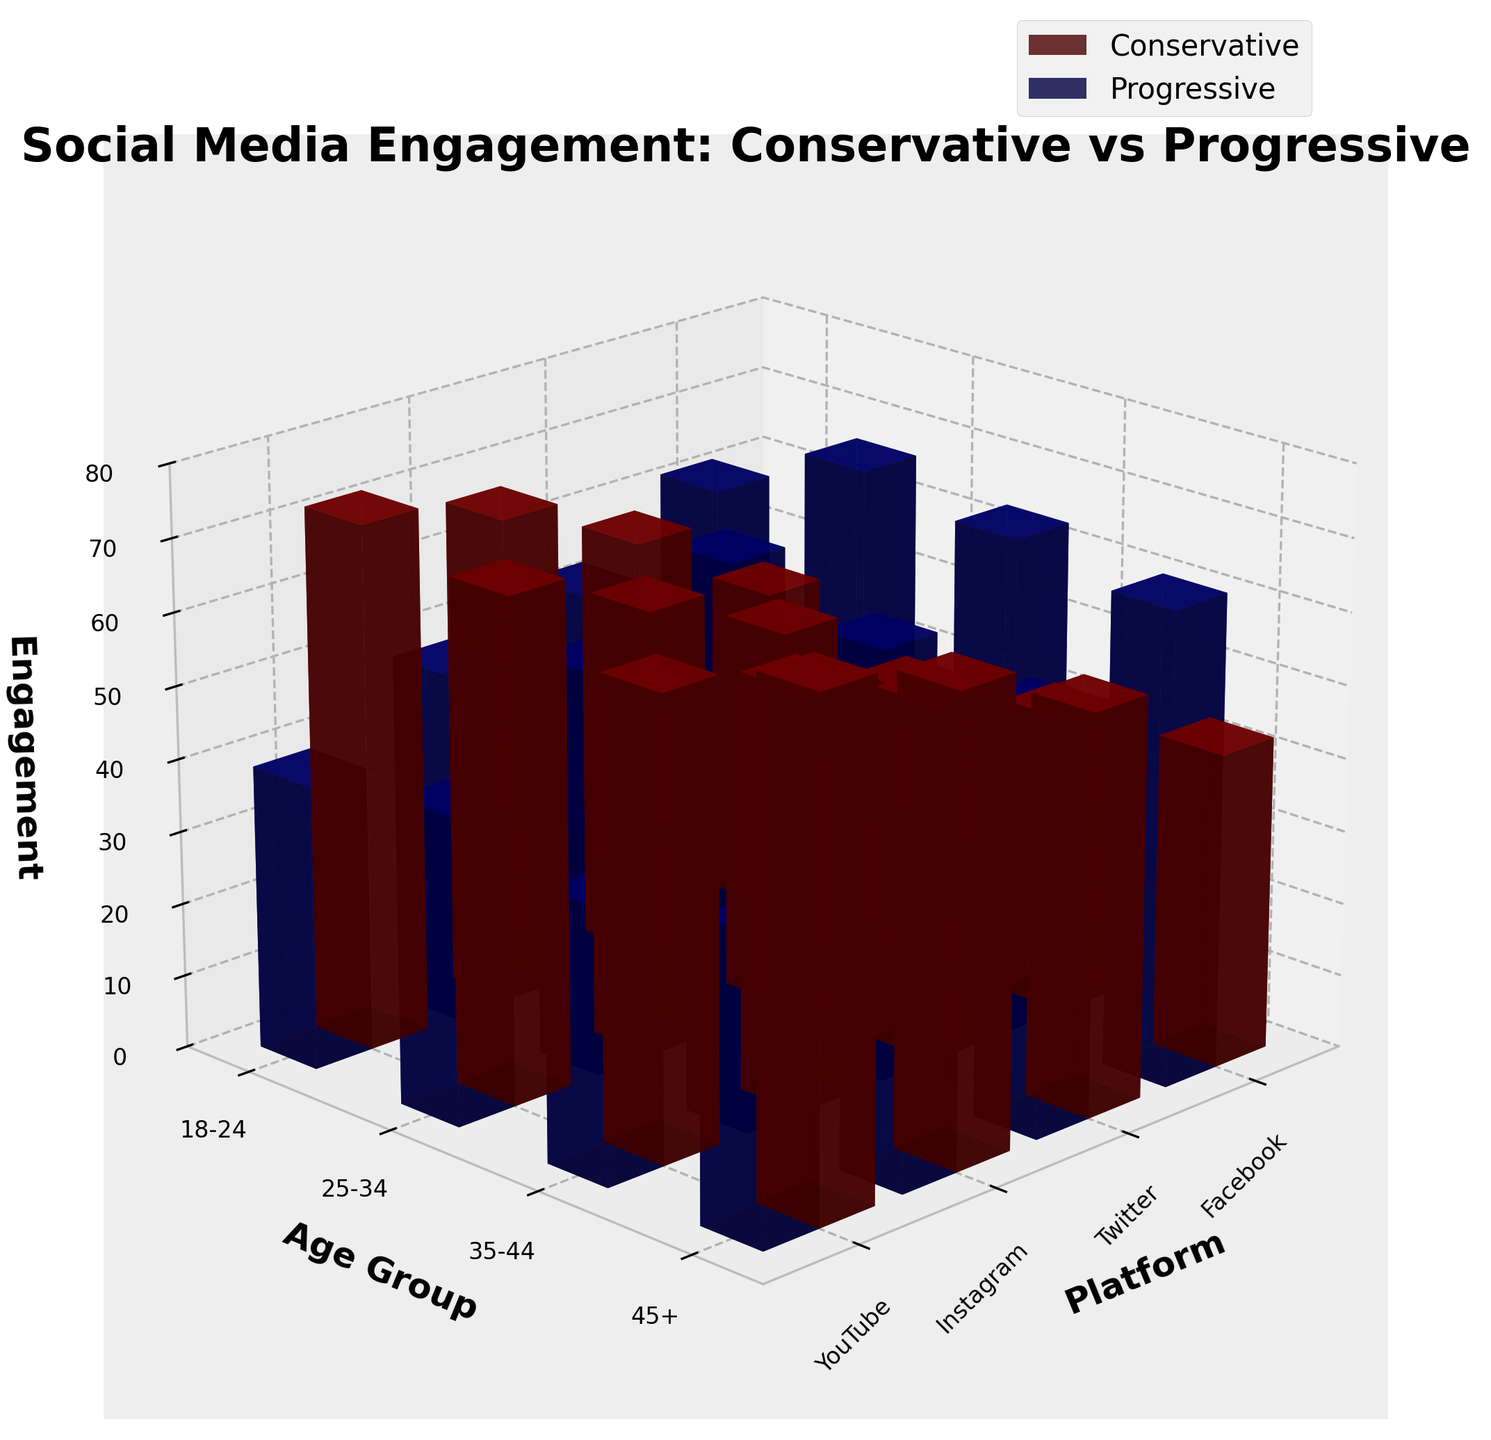What is the title of the figure? The title of the figure is located at the top of the plot and generally provides a summary of what the figure represents. In this case, the title mentions social media engagement for conservative vs. progressive content.
Answer: Social Media Engagement: Conservative vs Progressive How are the platforms and age groups represented on the axes? The platforms are labeled on the x-axis, while the age groups are labeled on the y-axis. The z-axis measures the engagement levels.
Answer: Platforms: x-axis, Age groups: y-axis, Engagement: z-axis Which platform shows the highest conservative engagement for the 45+ age group? To find the highest conservative engagement for the 45+ group, look at the bars for the 45+ age group across all platforms and compare their heights. The tallest bar represents the highest engagement. This bar appears on Facebook.
Answer: Facebook Compare the progressive engagement for the 18-24 age group on Twitter and Instagram. Which is higher? Analyze the heights of the bars for the 18-24 age group under Twitter and Instagram. The higher bar represents greater engagement. On Twitter, the engagement is higher for progressive content in this age group.
Answer: Twitter What is the difference in engagement between conservative and progressive content on Facebook for the 25-34 age group? Subtract the conservative engagement value from the progressive engagement value for Facebook in the 25-34 age group (53 - 58). The difference is 5.
Answer: 5 What is the average conservative engagement for YouTube across all age groups? Add the conservative engagement values for YouTube across all age groups and divide by the number of age groups (43 + 55 + 64 + 70) / 4. This results in 58.
Answer: 58 Which age group displays the largest disparity between conservative and progressive engagement on Instagram? Compare the absolute differences between conservative and progressive engagement values for each age group on Instagram: (68 - 41), (59 - 49), (51 - 57), (63 - 37). The largest disparity is for the 18-24 age group.
Answer: 18-24 On which platform do conservative users in the 35-44 age group show higher engagement compared to progressive users? Look at the engagement bars for both conservative and progressive users within the 35-44 age group across all platforms. Conservative users show higher engagement on Facebook, Twitter, Instagram, and YouTube.
Answer: Facebook, Twitter, Instagram, and YouTube By how much does conservative engagement exceed progressive engagement for the 45+ age group on YouTube? Subtract the progressive engagement value from the conservative engagement value for the 45+ age group on YouTube (70 - 41). The result is 29.
Answer: 29 